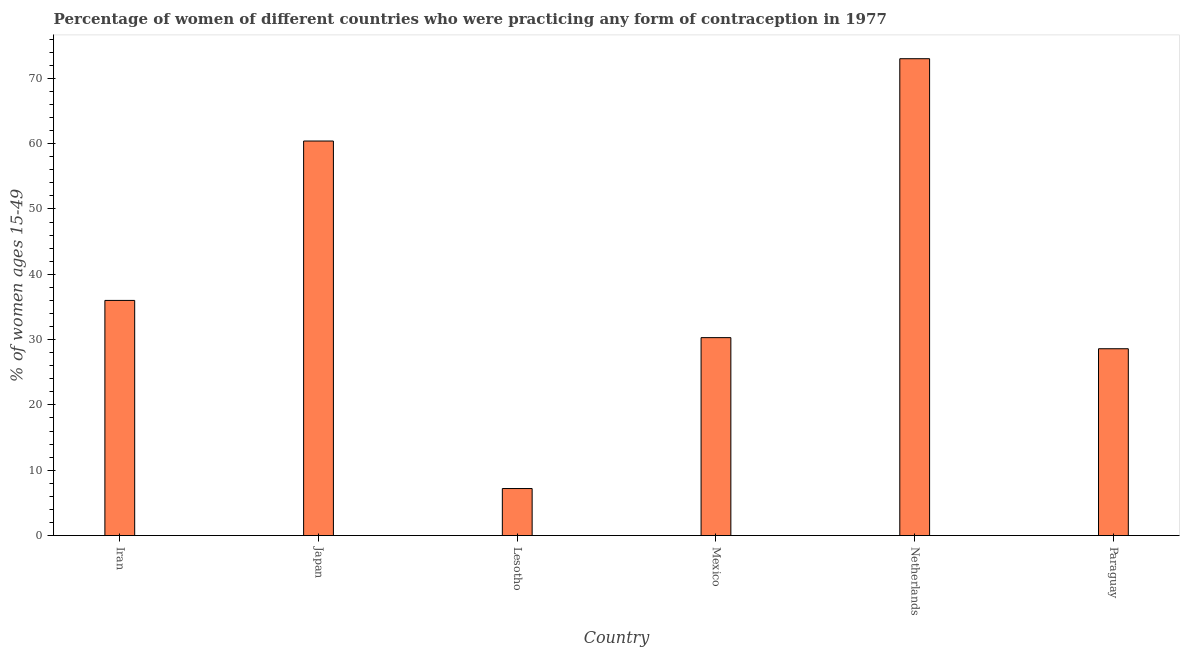Does the graph contain any zero values?
Your answer should be compact. No. Does the graph contain grids?
Offer a terse response. No. What is the title of the graph?
Ensure brevity in your answer.  Percentage of women of different countries who were practicing any form of contraception in 1977. What is the label or title of the X-axis?
Your response must be concise. Country. What is the label or title of the Y-axis?
Provide a succinct answer. % of women ages 15-49. What is the contraceptive prevalence in Mexico?
Your answer should be very brief. 30.3. Across all countries, what is the maximum contraceptive prevalence?
Your answer should be compact. 73. Across all countries, what is the minimum contraceptive prevalence?
Provide a short and direct response. 7.2. In which country was the contraceptive prevalence minimum?
Offer a very short reply. Lesotho. What is the sum of the contraceptive prevalence?
Offer a terse response. 235.5. What is the difference between the contraceptive prevalence in Netherlands and Paraguay?
Your response must be concise. 44.4. What is the average contraceptive prevalence per country?
Make the answer very short. 39.25. What is the median contraceptive prevalence?
Offer a very short reply. 33.15. What is the ratio of the contraceptive prevalence in Iran to that in Paraguay?
Make the answer very short. 1.26. Is the contraceptive prevalence in Mexico less than that in Netherlands?
Keep it short and to the point. Yes. Is the difference between the contraceptive prevalence in Lesotho and Mexico greater than the difference between any two countries?
Offer a very short reply. No. Is the sum of the contraceptive prevalence in Mexico and Netherlands greater than the maximum contraceptive prevalence across all countries?
Make the answer very short. Yes. What is the difference between the highest and the lowest contraceptive prevalence?
Your answer should be very brief. 65.8. In how many countries, is the contraceptive prevalence greater than the average contraceptive prevalence taken over all countries?
Your answer should be very brief. 2. What is the % of women ages 15-49 of Japan?
Provide a short and direct response. 60.4. What is the % of women ages 15-49 in Mexico?
Keep it short and to the point. 30.3. What is the % of women ages 15-49 in Netherlands?
Make the answer very short. 73. What is the % of women ages 15-49 of Paraguay?
Ensure brevity in your answer.  28.6. What is the difference between the % of women ages 15-49 in Iran and Japan?
Make the answer very short. -24.4. What is the difference between the % of women ages 15-49 in Iran and Lesotho?
Provide a short and direct response. 28.8. What is the difference between the % of women ages 15-49 in Iran and Mexico?
Provide a succinct answer. 5.7. What is the difference between the % of women ages 15-49 in Iran and Netherlands?
Your response must be concise. -37. What is the difference between the % of women ages 15-49 in Japan and Lesotho?
Provide a short and direct response. 53.2. What is the difference between the % of women ages 15-49 in Japan and Mexico?
Make the answer very short. 30.1. What is the difference between the % of women ages 15-49 in Japan and Paraguay?
Your response must be concise. 31.8. What is the difference between the % of women ages 15-49 in Lesotho and Mexico?
Give a very brief answer. -23.1. What is the difference between the % of women ages 15-49 in Lesotho and Netherlands?
Ensure brevity in your answer.  -65.8. What is the difference between the % of women ages 15-49 in Lesotho and Paraguay?
Your answer should be compact. -21.4. What is the difference between the % of women ages 15-49 in Mexico and Netherlands?
Provide a succinct answer. -42.7. What is the difference between the % of women ages 15-49 in Netherlands and Paraguay?
Give a very brief answer. 44.4. What is the ratio of the % of women ages 15-49 in Iran to that in Japan?
Provide a succinct answer. 0.6. What is the ratio of the % of women ages 15-49 in Iran to that in Lesotho?
Provide a short and direct response. 5. What is the ratio of the % of women ages 15-49 in Iran to that in Mexico?
Offer a very short reply. 1.19. What is the ratio of the % of women ages 15-49 in Iran to that in Netherlands?
Offer a very short reply. 0.49. What is the ratio of the % of women ages 15-49 in Iran to that in Paraguay?
Make the answer very short. 1.26. What is the ratio of the % of women ages 15-49 in Japan to that in Lesotho?
Keep it short and to the point. 8.39. What is the ratio of the % of women ages 15-49 in Japan to that in Mexico?
Your response must be concise. 1.99. What is the ratio of the % of women ages 15-49 in Japan to that in Netherlands?
Offer a terse response. 0.83. What is the ratio of the % of women ages 15-49 in Japan to that in Paraguay?
Provide a succinct answer. 2.11. What is the ratio of the % of women ages 15-49 in Lesotho to that in Mexico?
Ensure brevity in your answer.  0.24. What is the ratio of the % of women ages 15-49 in Lesotho to that in Netherlands?
Provide a short and direct response. 0.1. What is the ratio of the % of women ages 15-49 in Lesotho to that in Paraguay?
Provide a short and direct response. 0.25. What is the ratio of the % of women ages 15-49 in Mexico to that in Netherlands?
Your answer should be very brief. 0.41. What is the ratio of the % of women ages 15-49 in Mexico to that in Paraguay?
Make the answer very short. 1.06. What is the ratio of the % of women ages 15-49 in Netherlands to that in Paraguay?
Give a very brief answer. 2.55. 